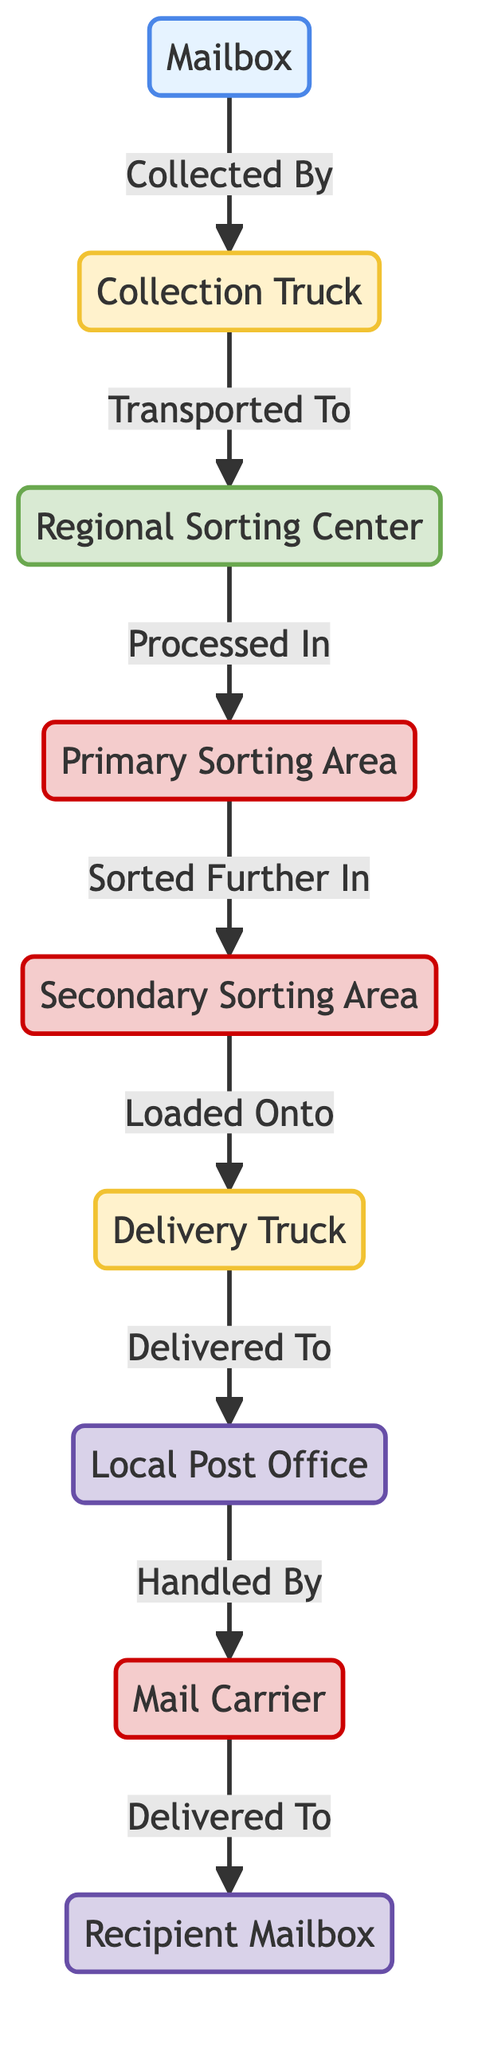What is the starting point of the workflow? The starting point of the workflow is the "Mailbox," which represents where the mail is collected initially before being transported.
Answer: Mailbox Which node is classified as a hub in the diagram? The "Regional Sorting Center" is identified as a hub since it connects multiple processes in the workflow.
Answer: Regional Sorting Center How many processes are there in the workflow? The diagram shows three processes: Primary Sorting Area, Secondary Sorting Area, and Mail Carrier. Therefore, the total number of processes is three.
Answer: 3 What is the last destination in the workflow? The last destination in the workflow is the "Recipient Mailbox," where the mail is ultimately delivered after going through various steps.
Answer: Recipient Mailbox Which node is responsible for handling mail after it arrives at the local post office? The "Mail Carrier" is responsible for handling the mail once it arrives at the local post office before it is delivered to the recipient.
Answer: Mail Carrier What is transported from the collection truck to the regional sorting center? The collection truck transports mail to the regional sorting center, which is indicated by the connection labeled "Transported To."
Answer: Mail How many edges are present in this diagram? The diagram has a total of eight edges, which represent the connections between the nodes in the workflow.
Answer: 8 What does the delivery truck do after it is loaded? After being loaded with mail at the secondary sorting area, the delivery truck is then delivered to the local post office. This flow shows the transportation of mail to the next stage.
Answer: Delivered To local post office Which two nodes are connected by the label "Sorted Further In"? The "Primary Sorting Area" and "Secondary Sorting Area" are connected by the label "Sorted Further In" as it indicates the flow of mail from further sorting.
Answer: Primary Sorting Area and Secondary Sorting Area 